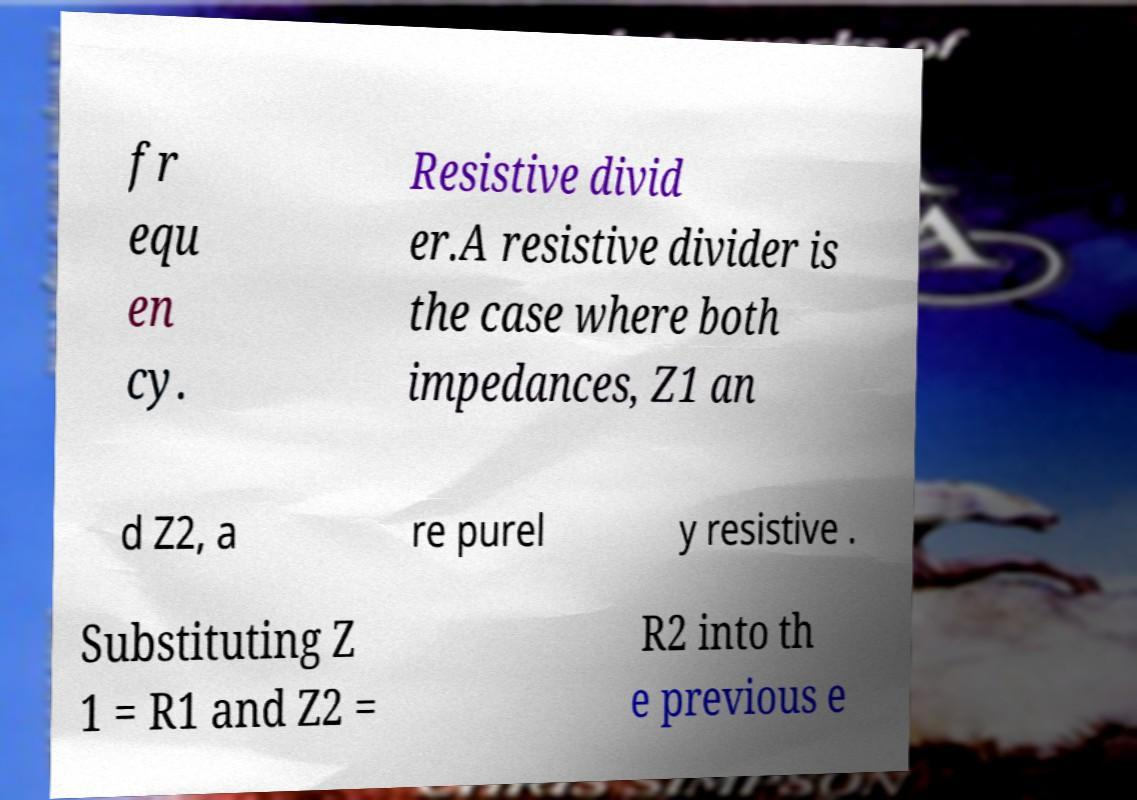Can you read and provide the text displayed in the image?This photo seems to have some interesting text. Can you extract and type it out for me? fr equ en cy. Resistive divid er.A resistive divider is the case where both impedances, Z1 an d Z2, a re purel y resistive . Substituting Z 1 = R1 and Z2 = R2 into th e previous e 